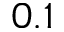Convert formula to latex. <formula><loc_0><loc_0><loc_500><loc_500>0 . 1</formula> 